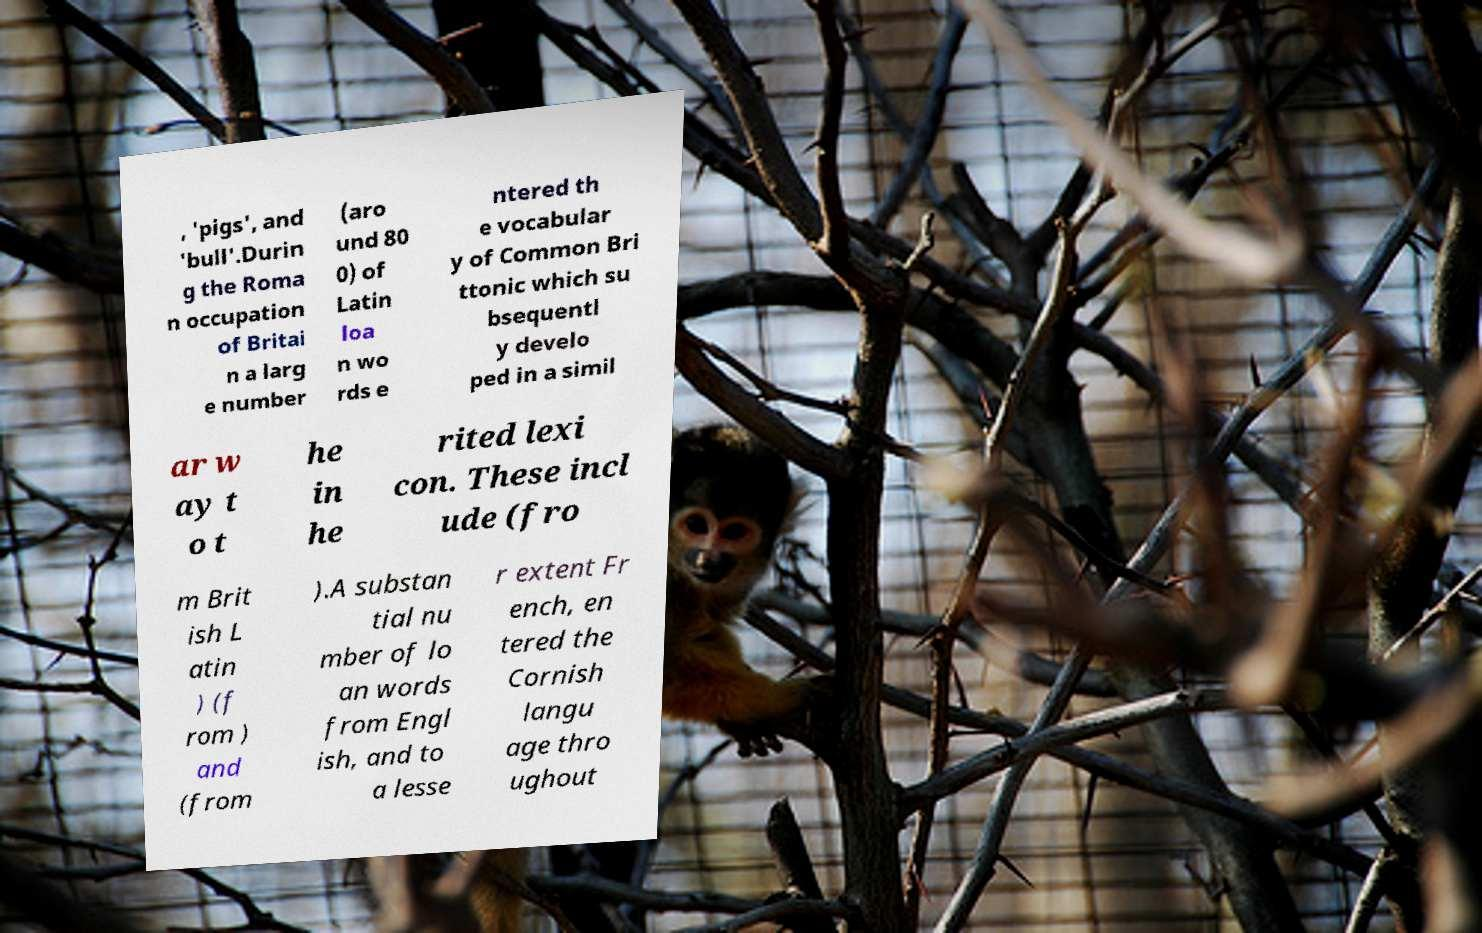Please identify and transcribe the text found in this image. , 'pigs', and 'bull'.Durin g the Roma n occupation of Britai n a larg e number (aro und 80 0) of Latin loa n wo rds e ntered th e vocabular y of Common Bri ttonic which su bsequentl y develo ped in a simil ar w ay t o t he in he rited lexi con. These incl ude (fro m Brit ish L atin ) (f rom ) and (from ).A substan tial nu mber of lo an words from Engl ish, and to a lesse r extent Fr ench, en tered the Cornish langu age thro ughout 